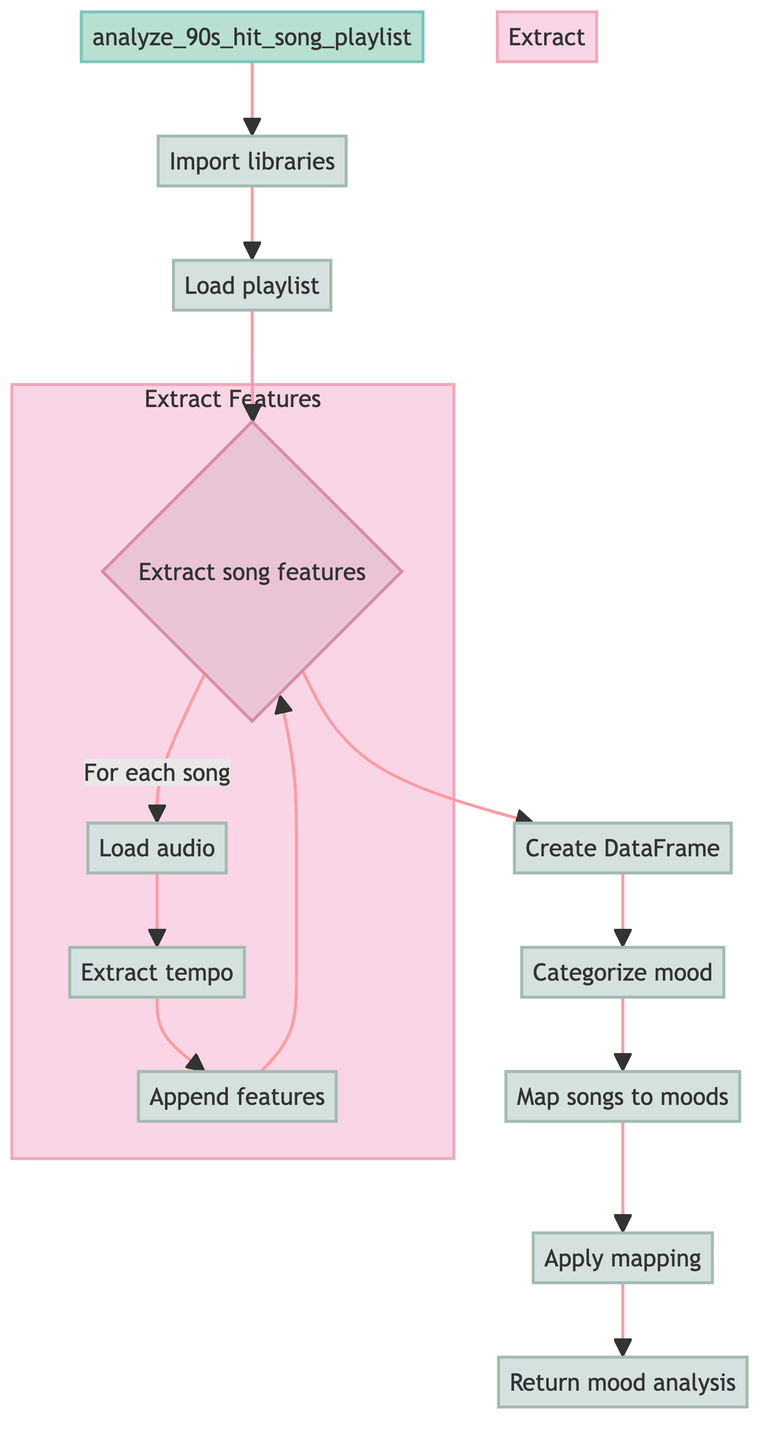What is the first step in the diagram? The first step in the diagram is "Import libraries". This is indicated as the starting point that connects directly to the next step in the process.
Answer: Import libraries How many dimensions are in the mood analysis DataFrame? The mood analysis DataFrame consists of three dimensions: Song, Mood, and MappedMood. This correlates with the "Return mood analysis" step where these three fields are explicitly mentioned.
Answer: Three What is the action taken after loading the playlist? After loading the playlist, the next action is to "Extract song features". This follows the loading step and indicates the flow of the process.
Answer: Extract song features What categorizes the mood of the songs? The mood of the songs is categorized based on their tempo, with a threshold set at 120 beats per minute to distinguish between 'Energetic' and 'Calm'. This is detailed in the "Categorize mood" step.
Answer: Tempo Which substep follows extracting the tempo? The substep that follows extracting the tempo is "Append features". This is sequentially placed after the tempo extraction as part of the feature extraction process.
Answer: Append features What is the purpose of the mood mapping? The purpose of the mood mapping is to assign a predefined mood to each song based on a specific mapping, which links song titles to their corresponding moods. This is shown in the "Map songs to moods" step.
Answer: Assign predefined mood How many main steps are there, excluding substeps? There are seven main steps in the flowchart excluding substeps. These represent the primary stages of the function's process outlined from the start to the conclusion of the mood analysis.
Answer: Seven What is the final action in the flowchart? The final action in the flowchart is to "Return mood analysis". This step concludes the process, summarizing all findings that were derived through the previous actions.
Answer: Return mood analysis In which step does the audio file get loaded? The audio file gets loaded in the "Load audio" substep. This action is part of the "Extract song features" decision node where each song’s audio file is accessed for analysis.
Answer: Load audio 